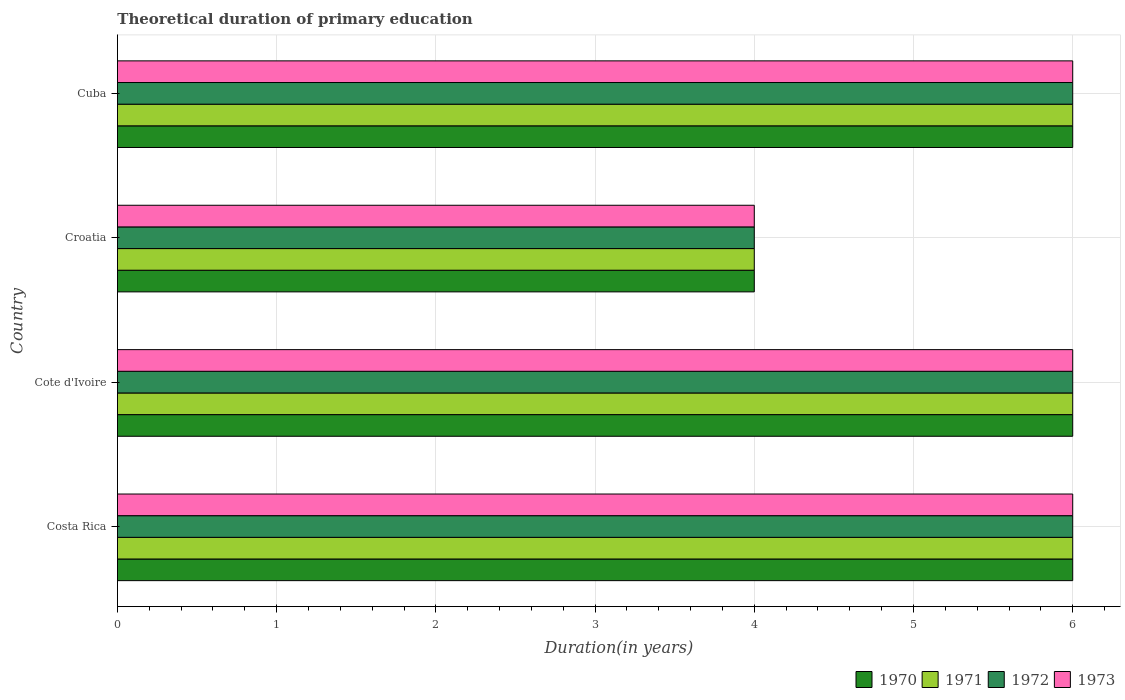Are the number of bars per tick equal to the number of legend labels?
Your answer should be very brief. Yes. Are the number of bars on each tick of the Y-axis equal?
Give a very brief answer. Yes. How many bars are there on the 1st tick from the bottom?
Make the answer very short. 4. What is the label of the 4th group of bars from the top?
Offer a very short reply. Costa Rica. What is the total theoretical duration of primary education in 1971 in Cote d'Ivoire?
Provide a short and direct response. 6. Across all countries, what is the minimum total theoretical duration of primary education in 1971?
Your response must be concise. 4. In which country was the total theoretical duration of primary education in 1971 minimum?
Provide a succinct answer. Croatia. What is the total total theoretical duration of primary education in 1972 in the graph?
Keep it short and to the point. 22. What is the difference between the total theoretical duration of primary education in 1971 in Costa Rica and that in Cote d'Ivoire?
Make the answer very short. 0. What is the difference between the total theoretical duration of primary education in 1971 in Croatia and the total theoretical duration of primary education in 1972 in Cote d'Ivoire?
Your response must be concise. -2. What is the average total theoretical duration of primary education in 1972 per country?
Give a very brief answer. 5.5. What is the ratio of the total theoretical duration of primary education in 1973 in Costa Rica to that in Cote d'Ivoire?
Make the answer very short. 1. Is the total theoretical duration of primary education in 1972 in Cote d'Ivoire less than that in Cuba?
Offer a very short reply. No. What is the difference between the highest and the second highest total theoretical duration of primary education in 1973?
Provide a succinct answer. 0. What is the difference between the highest and the lowest total theoretical duration of primary education in 1972?
Ensure brevity in your answer.  2. Is the sum of the total theoretical duration of primary education in 1972 in Costa Rica and Cuba greater than the maximum total theoretical duration of primary education in 1973 across all countries?
Provide a short and direct response. Yes. What does the 4th bar from the top in Cuba represents?
Make the answer very short. 1970. What does the 3rd bar from the bottom in Costa Rica represents?
Make the answer very short. 1972. Is it the case that in every country, the sum of the total theoretical duration of primary education in 1973 and total theoretical duration of primary education in 1972 is greater than the total theoretical duration of primary education in 1970?
Your answer should be very brief. Yes. How many bars are there?
Make the answer very short. 16. How many legend labels are there?
Your answer should be compact. 4. What is the title of the graph?
Your answer should be compact. Theoretical duration of primary education. What is the label or title of the X-axis?
Make the answer very short. Duration(in years). What is the label or title of the Y-axis?
Your response must be concise. Country. What is the Duration(in years) of 1970 in Costa Rica?
Give a very brief answer. 6. What is the Duration(in years) in 1971 in Costa Rica?
Keep it short and to the point. 6. What is the Duration(in years) of 1972 in Costa Rica?
Provide a short and direct response. 6. What is the Duration(in years) of 1973 in Costa Rica?
Make the answer very short. 6. What is the Duration(in years) of 1971 in Cote d'Ivoire?
Your response must be concise. 6. What is the Duration(in years) in 1971 in Croatia?
Offer a terse response. 4. What is the Duration(in years) of 1972 in Croatia?
Keep it short and to the point. 4. What is the Duration(in years) of 1973 in Croatia?
Ensure brevity in your answer.  4. What is the Duration(in years) in 1971 in Cuba?
Offer a terse response. 6. What is the Duration(in years) in 1972 in Cuba?
Your response must be concise. 6. Across all countries, what is the maximum Duration(in years) in 1970?
Ensure brevity in your answer.  6. Across all countries, what is the maximum Duration(in years) in 1971?
Offer a very short reply. 6. Across all countries, what is the minimum Duration(in years) of 1971?
Provide a succinct answer. 4. Across all countries, what is the minimum Duration(in years) in 1972?
Ensure brevity in your answer.  4. Across all countries, what is the minimum Duration(in years) in 1973?
Offer a very short reply. 4. What is the total Duration(in years) in 1972 in the graph?
Make the answer very short. 22. What is the difference between the Duration(in years) in 1971 in Costa Rica and that in Croatia?
Give a very brief answer. 2. What is the difference between the Duration(in years) in 1973 in Costa Rica and that in Croatia?
Your answer should be compact. 2. What is the difference between the Duration(in years) of 1970 in Costa Rica and that in Cuba?
Make the answer very short. 0. What is the difference between the Duration(in years) of 1972 in Costa Rica and that in Cuba?
Offer a very short reply. 0. What is the difference between the Duration(in years) in 1970 in Cote d'Ivoire and that in Croatia?
Offer a terse response. 2. What is the difference between the Duration(in years) in 1972 in Cote d'Ivoire and that in Croatia?
Ensure brevity in your answer.  2. What is the difference between the Duration(in years) in 1970 in Cote d'Ivoire and that in Cuba?
Give a very brief answer. 0. What is the difference between the Duration(in years) of 1973 in Cote d'Ivoire and that in Cuba?
Your answer should be very brief. 0. What is the difference between the Duration(in years) of 1970 in Croatia and that in Cuba?
Offer a very short reply. -2. What is the difference between the Duration(in years) of 1972 in Croatia and that in Cuba?
Give a very brief answer. -2. What is the difference between the Duration(in years) in 1970 in Costa Rica and the Duration(in years) in 1972 in Cote d'Ivoire?
Provide a succinct answer. 0. What is the difference between the Duration(in years) in 1970 in Costa Rica and the Duration(in years) in 1973 in Cote d'Ivoire?
Your answer should be very brief. 0. What is the difference between the Duration(in years) of 1971 in Costa Rica and the Duration(in years) of 1972 in Cote d'Ivoire?
Provide a succinct answer. 0. What is the difference between the Duration(in years) of 1971 in Costa Rica and the Duration(in years) of 1972 in Croatia?
Your answer should be very brief. 2. What is the difference between the Duration(in years) of 1971 in Costa Rica and the Duration(in years) of 1973 in Croatia?
Your response must be concise. 2. What is the difference between the Duration(in years) of 1970 in Costa Rica and the Duration(in years) of 1973 in Cuba?
Provide a short and direct response. 0. What is the difference between the Duration(in years) of 1971 in Cote d'Ivoire and the Duration(in years) of 1972 in Croatia?
Offer a terse response. 2. What is the difference between the Duration(in years) of 1971 in Cote d'Ivoire and the Duration(in years) of 1973 in Croatia?
Give a very brief answer. 2. What is the difference between the Duration(in years) in 1972 in Cote d'Ivoire and the Duration(in years) in 1973 in Croatia?
Your answer should be very brief. 2. What is the difference between the Duration(in years) of 1970 in Cote d'Ivoire and the Duration(in years) of 1972 in Cuba?
Give a very brief answer. 0. What is the difference between the Duration(in years) of 1971 in Cote d'Ivoire and the Duration(in years) of 1972 in Cuba?
Give a very brief answer. 0. What is the difference between the Duration(in years) in 1971 in Cote d'Ivoire and the Duration(in years) in 1973 in Cuba?
Make the answer very short. 0. What is the difference between the Duration(in years) of 1972 in Cote d'Ivoire and the Duration(in years) of 1973 in Cuba?
Your answer should be compact. 0. What is the average Duration(in years) in 1970 per country?
Keep it short and to the point. 5.5. What is the average Duration(in years) of 1972 per country?
Make the answer very short. 5.5. What is the difference between the Duration(in years) in 1970 and Duration(in years) in 1973 in Costa Rica?
Keep it short and to the point. 0. What is the difference between the Duration(in years) of 1972 and Duration(in years) of 1973 in Costa Rica?
Your response must be concise. 0. What is the difference between the Duration(in years) in 1970 and Duration(in years) in 1973 in Cote d'Ivoire?
Your response must be concise. 0. What is the difference between the Duration(in years) of 1971 and Duration(in years) of 1972 in Cote d'Ivoire?
Ensure brevity in your answer.  0. What is the difference between the Duration(in years) in 1970 and Duration(in years) in 1971 in Croatia?
Provide a succinct answer. 0. What is the difference between the Duration(in years) of 1970 and Duration(in years) of 1972 in Croatia?
Your answer should be compact. 0. What is the difference between the Duration(in years) of 1970 and Duration(in years) of 1973 in Croatia?
Provide a short and direct response. 0. What is the difference between the Duration(in years) of 1971 and Duration(in years) of 1973 in Croatia?
Provide a succinct answer. 0. What is the difference between the Duration(in years) in 1972 and Duration(in years) in 1973 in Croatia?
Your answer should be very brief. 0. What is the difference between the Duration(in years) of 1970 and Duration(in years) of 1973 in Cuba?
Give a very brief answer. 0. What is the difference between the Duration(in years) of 1971 and Duration(in years) of 1973 in Cuba?
Give a very brief answer. 0. What is the ratio of the Duration(in years) in 1971 in Costa Rica to that in Cote d'Ivoire?
Your answer should be very brief. 1. What is the ratio of the Duration(in years) in 1973 in Costa Rica to that in Cote d'Ivoire?
Your response must be concise. 1. What is the ratio of the Duration(in years) of 1971 in Costa Rica to that in Croatia?
Your response must be concise. 1.5. What is the ratio of the Duration(in years) of 1972 in Costa Rica to that in Croatia?
Offer a terse response. 1.5. What is the ratio of the Duration(in years) in 1973 in Costa Rica to that in Croatia?
Keep it short and to the point. 1.5. What is the ratio of the Duration(in years) of 1970 in Cote d'Ivoire to that in Croatia?
Keep it short and to the point. 1.5. What is the ratio of the Duration(in years) of 1971 in Cote d'Ivoire to that in Croatia?
Ensure brevity in your answer.  1.5. What is the ratio of the Duration(in years) of 1972 in Cote d'Ivoire to that in Croatia?
Your response must be concise. 1.5. What is the ratio of the Duration(in years) in 1970 in Cote d'Ivoire to that in Cuba?
Offer a very short reply. 1. What is the ratio of the Duration(in years) in 1972 in Cote d'Ivoire to that in Cuba?
Ensure brevity in your answer.  1. What is the ratio of the Duration(in years) of 1972 in Croatia to that in Cuba?
Your answer should be very brief. 0.67. What is the difference between the highest and the second highest Duration(in years) in 1971?
Provide a succinct answer. 0. What is the difference between the highest and the second highest Duration(in years) in 1972?
Your answer should be very brief. 0. What is the difference between the highest and the second highest Duration(in years) in 1973?
Your answer should be very brief. 0. What is the difference between the highest and the lowest Duration(in years) of 1971?
Provide a succinct answer. 2. 